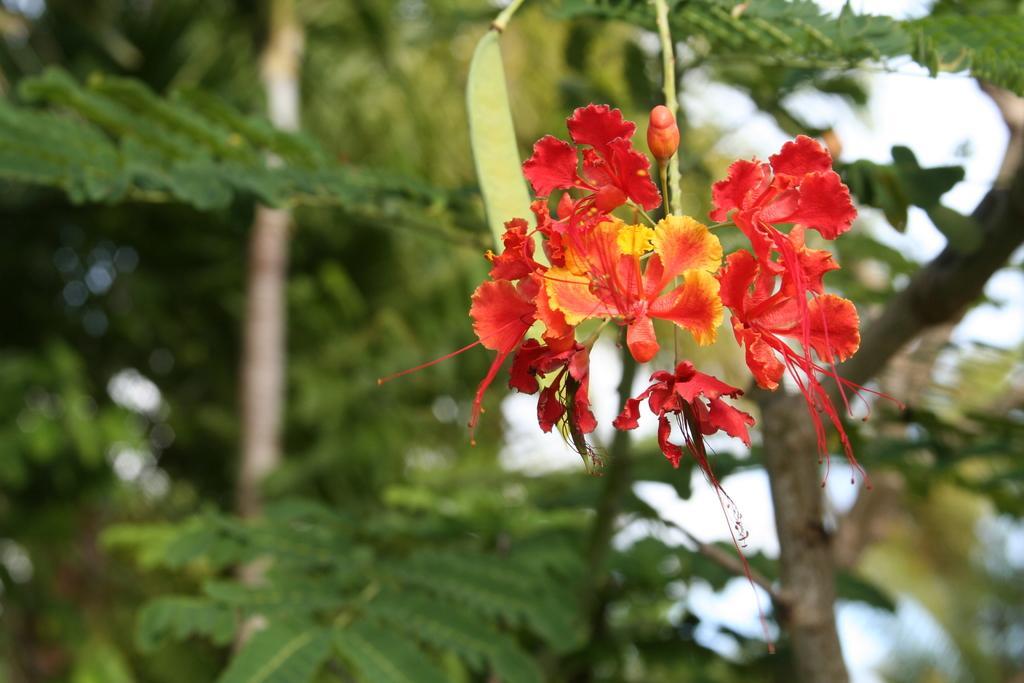How would you summarize this image in a sentence or two? In this picture I can see flowers in the middle, in the background there are trees. 